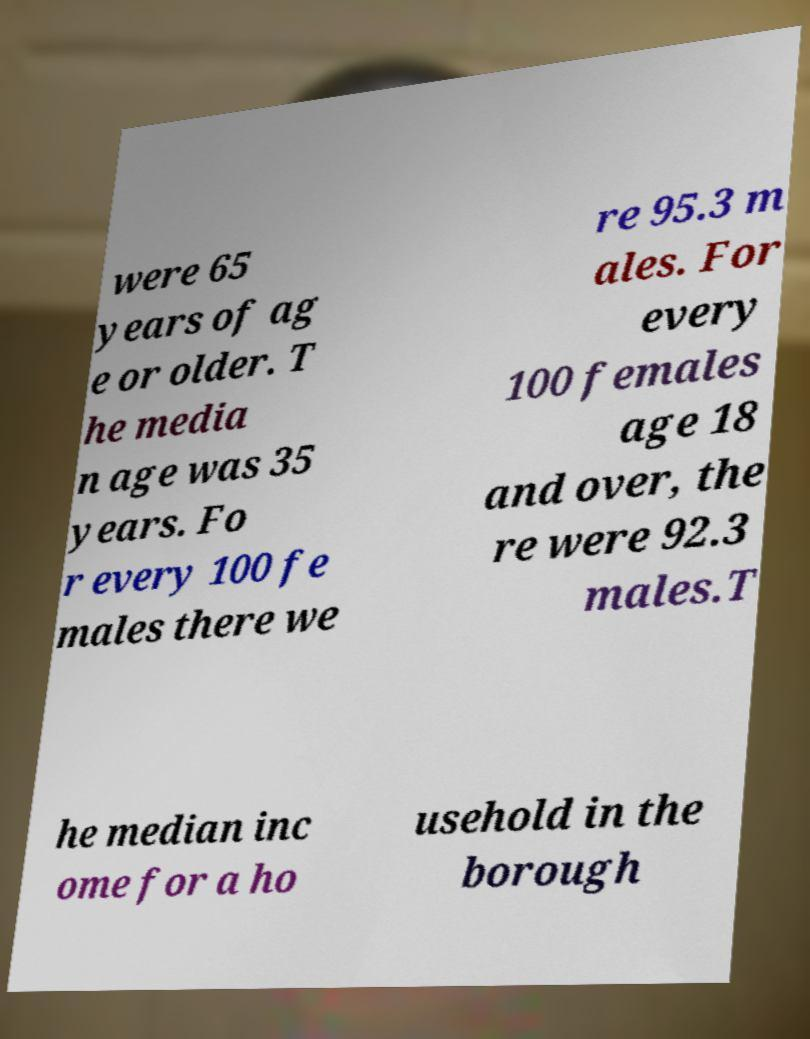Please read and relay the text visible in this image. What does it say? were 65 years of ag e or older. T he media n age was 35 years. Fo r every 100 fe males there we re 95.3 m ales. For every 100 females age 18 and over, the re were 92.3 males.T he median inc ome for a ho usehold in the borough 